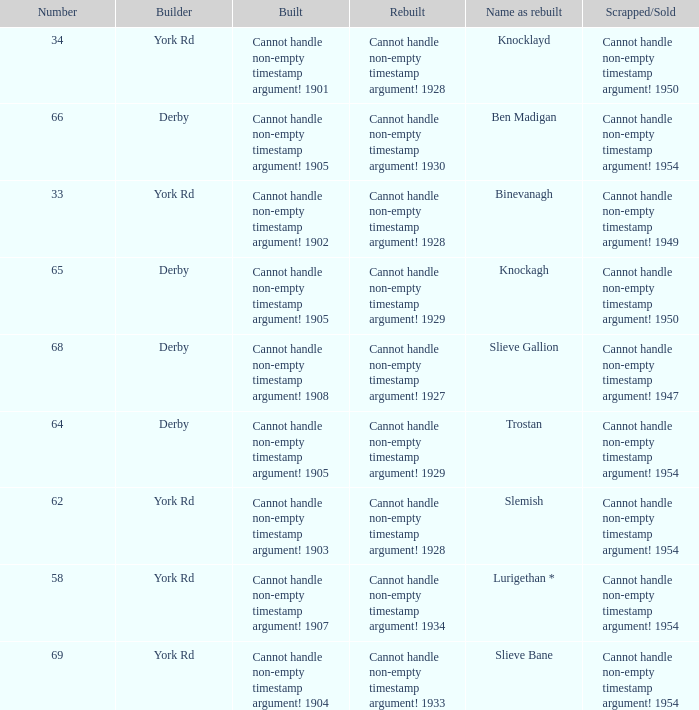Which Rebuilt has a Name as rebuilt of binevanagh? Cannot handle non-empty timestamp argument! 1928. Could you help me parse every detail presented in this table? {'header': ['Number', 'Builder', 'Built', 'Rebuilt', 'Name as rebuilt', 'Scrapped/Sold'], 'rows': [['34', 'York Rd', 'Cannot handle non-empty timestamp argument! 1901', 'Cannot handle non-empty timestamp argument! 1928', 'Knocklayd', 'Cannot handle non-empty timestamp argument! 1950'], ['66', 'Derby', 'Cannot handle non-empty timestamp argument! 1905', 'Cannot handle non-empty timestamp argument! 1930', 'Ben Madigan', 'Cannot handle non-empty timestamp argument! 1954'], ['33', 'York Rd', 'Cannot handle non-empty timestamp argument! 1902', 'Cannot handle non-empty timestamp argument! 1928', 'Binevanagh', 'Cannot handle non-empty timestamp argument! 1949'], ['65', 'Derby', 'Cannot handle non-empty timestamp argument! 1905', 'Cannot handle non-empty timestamp argument! 1929', 'Knockagh', 'Cannot handle non-empty timestamp argument! 1950'], ['68', 'Derby', 'Cannot handle non-empty timestamp argument! 1908', 'Cannot handle non-empty timestamp argument! 1927', 'Slieve Gallion', 'Cannot handle non-empty timestamp argument! 1947'], ['64', 'Derby', 'Cannot handle non-empty timestamp argument! 1905', 'Cannot handle non-empty timestamp argument! 1929', 'Trostan', 'Cannot handle non-empty timestamp argument! 1954'], ['62', 'York Rd', 'Cannot handle non-empty timestamp argument! 1903', 'Cannot handle non-empty timestamp argument! 1928', 'Slemish', 'Cannot handle non-empty timestamp argument! 1954'], ['58', 'York Rd', 'Cannot handle non-empty timestamp argument! 1907', 'Cannot handle non-empty timestamp argument! 1934', 'Lurigethan *', 'Cannot handle non-empty timestamp argument! 1954'], ['69', 'York Rd', 'Cannot handle non-empty timestamp argument! 1904', 'Cannot handle non-empty timestamp argument! 1933', 'Slieve Bane', 'Cannot handle non-empty timestamp argument! 1954']]} 